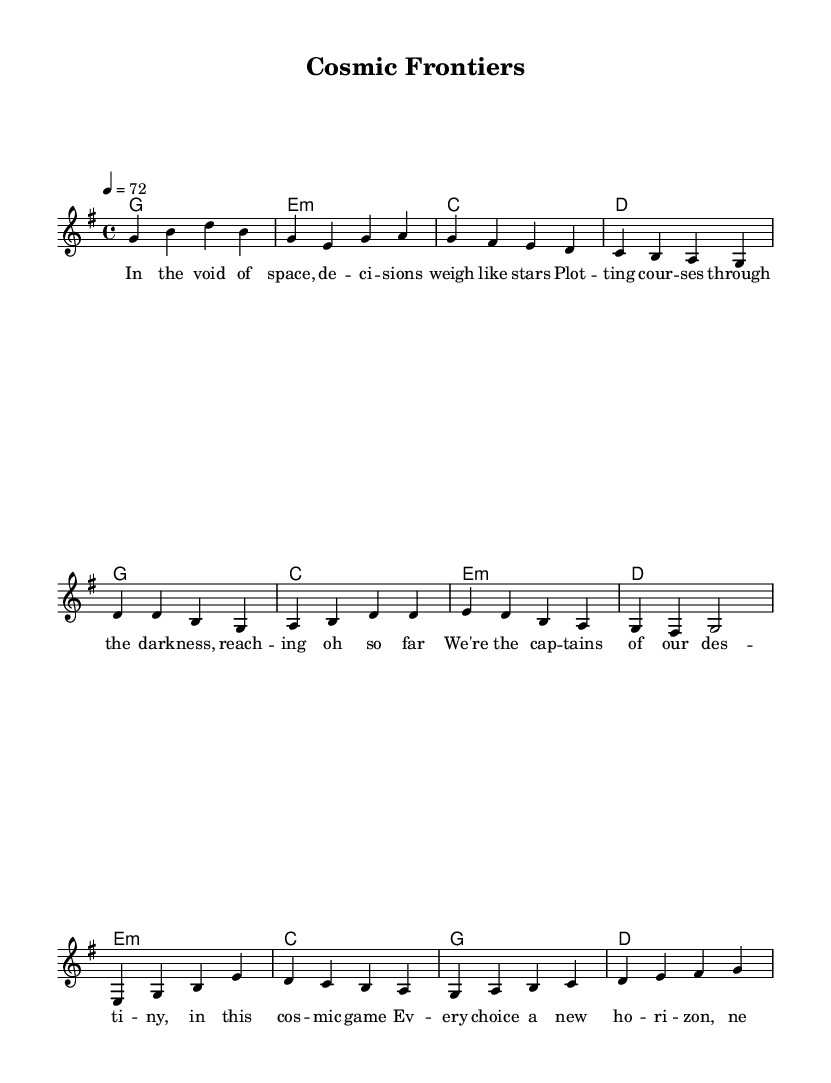What is the key signature of this music? The key signature is indicated at the beginning of the sheet music, showing one sharp (F#) which corresponds to G major.
Answer: G major What is the time signature of this music? The time signature is placed at the beginning, indicating that there are four beats in each measure, denoted as 4/4.
Answer: 4/4 What is the tempo marking for this piece? The tempo marking indicates the speed of the piece, which is set to 72 beats per minute (BPM) and is noted at the start of the score.
Answer: 72 How many measures does the melody in the verse have? The verse melody can be counted directly from the notation, which consists of four measures in total as represented by the notation groups.
Answer: Four What is the primary theme of the lyrics? The lyrics discuss making decisions and navigating in a cosmic setting, symbolizing leadership and choosing one's destiny. This can be inferred from the repeated phrases in the verses and chorus about decision-making.
Answer: Leadership What chord follows the G major chord in the bridge section? By examining the chord progression in the bridge section, the G major chord is followed by a D major chord, as shown in the written harmony.
Answer: D How does the chorus relate to the verses in terms of lyrical content? The chorus reinforces the message of the verses by emphasizing themes of destiny and choice, creating a cohesive narrative throughout the song. This connection is identified by analyzing the central ideas presented in both sections.
Answer: Cosmic game 